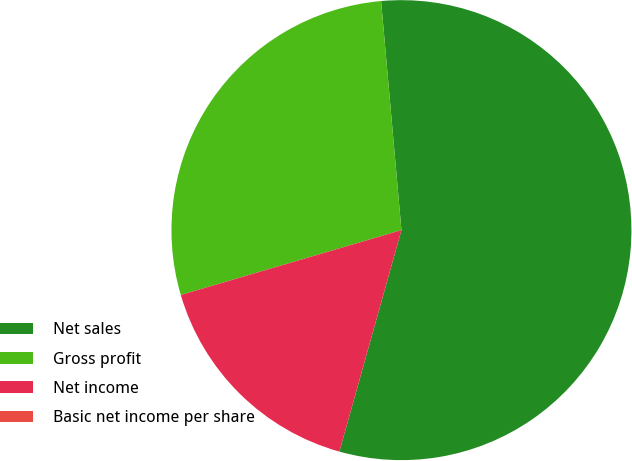<chart> <loc_0><loc_0><loc_500><loc_500><pie_chart><fcel>Net sales<fcel>Gross profit<fcel>Net income<fcel>Basic net income per share<nl><fcel>55.76%<fcel>28.14%<fcel>16.1%<fcel>0.0%<nl></chart> 